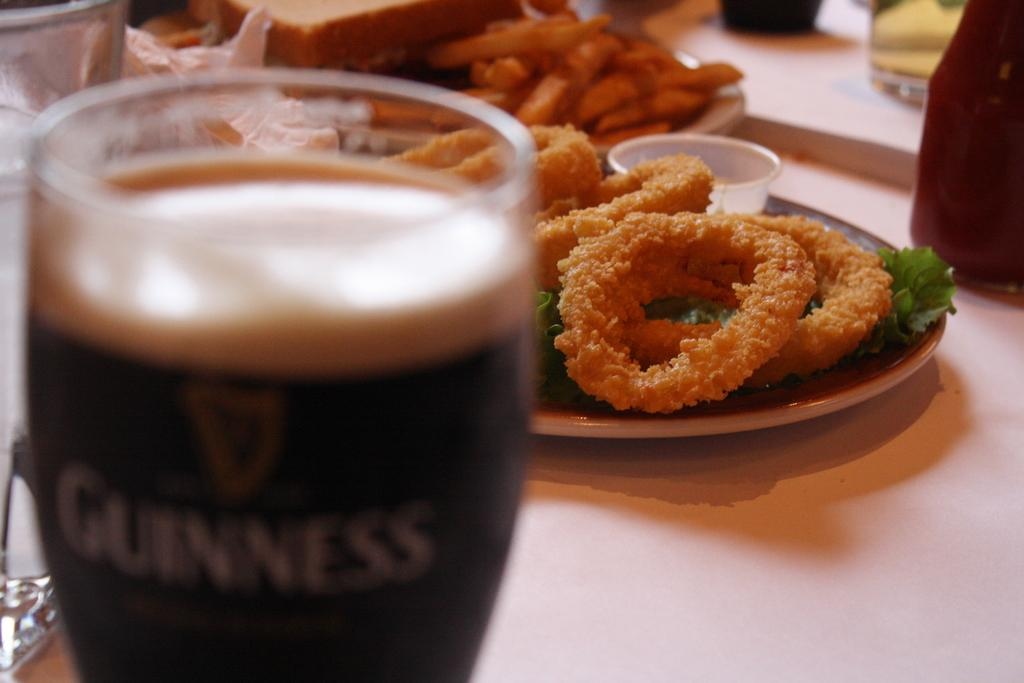What object is located in the foreground area of the image? There is a glass in the foreground area of the image. What can be seen in the background of the image? There are food items in the background of the image. What type of record is being played in the image? There is no record or any indication of music or sound being played in the image. 